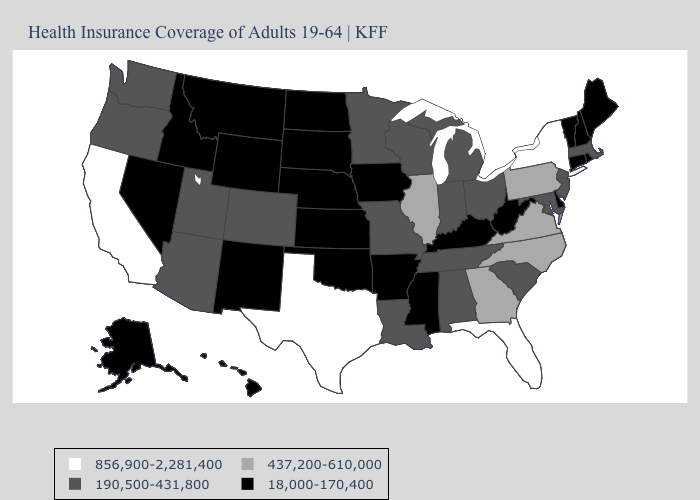What is the value of California?
Write a very short answer. 856,900-2,281,400. What is the lowest value in states that border Indiana?
Concise answer only. 18,000-170,400. Among the states that border Maryland , which have the lowest value?
Answer briefly. Delaware, West Virginia. Does Colorado have the lowest value in the West?
Concise answer only. No. What is the value of New Mexico?
Keep it brief. 18,000-170,400. Which states have the lowest value in the USA?
Quick response, please. Alaska, Arkansas, Connecticut, Delaware, Hawaii, Idaho, Iowa, Kansas, Kentucky, Maine, Mississippi, Montana, Nebraska, Nevada, New Hampshire, New Mexico, North Dakota, Oklahoma, Rhode Island, South Dakota, Vermont, West Virginia, Wyoming. Does the map have missing data?
Quick response, please. No. Does the map have missing data?
Keep it brief. No. Does the first symbol in the legend represent the smallest category?
Give a very brief answer. No. Among the states that border Alabama , which have the highest value?
Be succinct. Florida. Does the first symbol in the legend represent the smallest category?
Quick response, please. No. Among the states that border Colorado , does Arizona have the lowest value?
Concise answer only. No. Name the states that have a value in the range 18,000-170,400?
Answer briefly. Alaska, Arkansas, Connecticut, Delaware, Hawaii, Idaho, Iowa, Kansas, Kentucky, Maine, Mississippi, Montana, Nebraska, Nevada, New Hampshire, New Mexico, North Dakota, Oklahoma, Rhode Island, South Dakota, Vermont, West Virginia, Wyoming. Among the states that border North Carolina , does Tennessee have the highest value?
Write a very short answer. No. Name the states that have a value in the range 437,200-610,000?
Short answer required. Georgia, Illinois, North Carolina, Pennsylvania, Virginia. 